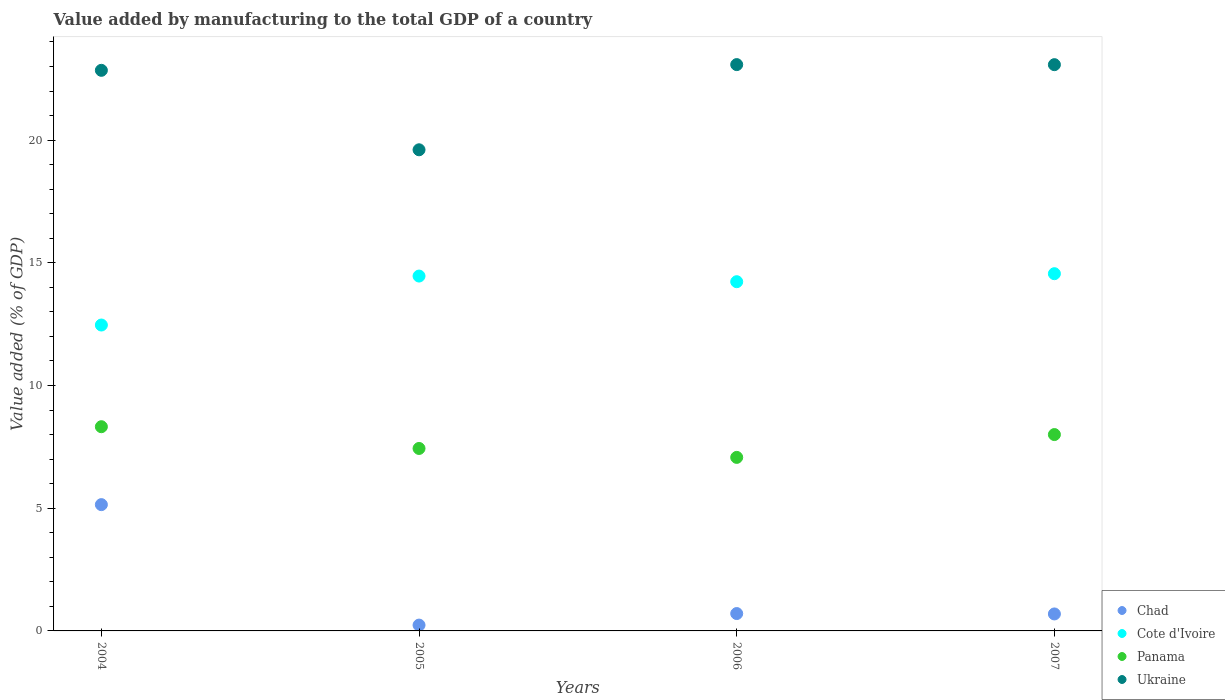What is the value added by manufacturing to the total GDP in Cote d'Ivoire in 2004?
Give a very brief answer. 12.47. Across all years, what is the maximum value added by manufacturing to the total GDP in Panama?
Offer a terse response. 8.32. Across all years, what is the minimum value added by manufacturing to the total GDP in Ukraine?
Keep it short and to the point. 19.61. In which year was the value added by manufacturing to the total GDP in Panama minimum?
Your answer should be compact. 2006. What is the total value added by manufacturing to the total GDP in Cote d'Ivoire in the graph?
Your answer should be very brief. 55.71. What is the difference between the value added by manufacturing to the total GDP in Chad in 2004 and that in 2006?
Ensure brevity in your answer.  4.44. What is the difference between the value added by manufacturing to the total GDP in Panama in 2006 and the value added by manufacturing to the total GDP in Cote d'Ivoire in 2004?
Your answer should be very brief. -5.39. What is the average value added by manufacturing to the total GDP in Cote d'Ivoire per year?
Make the answer very short. 13.93. In the year 2005, what is the difference between the value added by manufacturing to the total GDP in Cote d'Ivoire and value added by manufacturing to the total GDP in Ukraine?
Offer a very short reply. -5.15. What is the ratio of the value added by manufacturing to the total GDP in Cote d'Ivoire in 2006 to that in 2007?
Make the answer very short. 0.98. What is the difference between the highest and the second highest value added by manufacturing to the total GDP in Panama?
Keep it short and to the point. 0.32. What is the difference between the highest and the lowest value added by manufacturing to the total GDP in Panama?
Keep it short and to the point. 1.25. Is it the case that in every year, the sum of the value added by manufacturing to the total GDP in Ukraine and value added by manufacturing to the total GDP in Cote d'Ivoire  is greater than the value added by manufacturing to the total GDP in Panama?
Make the answer very short. Yes. Is the value added by manufacturing to the total GDP in Chad strictly less than the value added by manufacturing to the total GDP in Panama over the years?
Your answer should be very brief. Yes. How many dotlines are there?
Keep it short and to the point. 4. Are the values on the major ticks of Y-axis written in scientific E-notation?
Make the answer very short. No. Does the graph contain any zero values?
Offer a terse response. No. Where does the legend appear in the graph?
Provide a succinct answer. Bottom right. What is the title of the graph?
Provide a short and direct response. Value added by manufacturing to the total GDP of a country. What is the label or title of the Y-axis?
Your answer should be compact. Value added (% of GDP). What is the Value added (% of GDP) in Chad in 2004?
Give a very brief answer. 5.15. What is the Value added (% of GDP) in Cote d'Ivoire in 2004?
Your response must be concise. 12.47. What is the Value added (% of GDP) of Panama in 2004?
Your response must be concise. 8.32. What is the Value added (% of GDP) of Ukraine in 2004?
Give a very brief answer. 22.84. What is the Value added (% of GDP) of Chad in 2005?
Ensure brevity in your answer.  0.24. What is the Value added (% of GDP) of Cote d'Ivoire in 2005?
Your answer should be very brief. 14.46. What is the Value added (% of GDP) in Panama in 2005?
Your response must be concise. 7.44. What is the Value added (% of GDP) in Ukraine in 2005?
Keep it short and to the point. 19.61. What is the Value added (% of GDP) in Chad in 2006?
Offer a terse response. 0.71. What is the Value added (% of GDP) in Cote d'Ivoire in 2006?
Offer a terse response. 14.23. What is the Value added (% of GDP) in Panama in 2006?
Keep it short and to the point. 7.07. What is the Value added (% of GDP) in Ukraine in 2006?
Your response must be concise. 23.08. What is the Value added (% of GDP) in Chad in 2007?
Provide a succinct answer. 0.69. What is the Value added (% of GDP) in Cote d'Ivoire in 2007?
Offer a terse response. 14.56. What is the Value added (% of GDP) in Panama in 2007?
Your response must be concise. 8. What is the Value added (% of GDP) of Ukraine in 2007?
Provide a succinct answer. 23.07. Across all years, what is the maximum Value added (% of GDP) of Chad?
Make the answer very short. 5.15. Across all years, what is the maximum Value added (% of GDP) in Cote d'Ivoire?
Your response must be concise. 14.56. Across all years, what is the maximum Value added (% of GDP) in Panama?
Your answer should be compact. 8.32. Across all years, what is the maximum Value added (% of GDP) of Ukraine?
Make the answer very short. 23.08. Across all years, what is the minimum Value added (% of GDP) in Chad?
Offer a very short reply. 0.24. Across all years, what is the minimum Value added (% of GDP) in Cote d'Ivoire?
Your answer should be compact. 12.47. Across all years, what is the minimum Value added (% of GDP) in Panama?
Your answer should be very brief. 7.07. Across all years, what is the minimum Value added (% of GDP) in Ukraine?
Offer a terse response. 19.61. What is the total Value added (% of GDP) of Chad in the graph?
Ensure brevity in your answer.  6.78. What is the total Value added (% of GDP) of Cote d'Ivoire in the graph?
Offer a very short reply. 55.71. What is the total Value added (% of GDP) of Panama in the graph?
Offer a terse response. 30.83. What is the total Value added (% of GDP) in Ukraine in the graph?
Your answer should be very brief. 88.6. What is the difference between the Value added (% of GDP) of Chad in 2004 and that in 2005?
Ensure brevity in your answer.  4.91. What is the difference between the Value added (% of GDP) in Cote d'Ivoire in 2004 and that in 2005?
Provide a short and direct response. -2. What is the difference between the Value added (% of GDP) of Panama in 2004 and that in 2005?
Ensure brevity in your answer.  0.89. What is the difference between the Value added (% of GDP) in Ukraine in 2004 and that in 2005?
Provide a short and direct response. 3.24. What is the difference between the Value added (% of GDP) of Chad in 2004 and that in 2006?
Ensure brevity in your answer.  4.44. What is the difference between the Value added (% of GDP) of Cote d'Ivoire in 2004 and that in 2006?
Provide a succinct answer. -1.77. What is the difference between the Value added (% of GDP) of Panama in 2004 and that in 2006?
Your answer should be very brief. 1.25. What is the difference between the Value added (% of GDP) in Ukraine in 2004 and that in 2006?
Make the answer very short. -0.23. What is the difference between the Value added (% of GDP) in Chad in 2004 and that in 2007?
Your answer should be compact. 4.45. What is the difference between the Value added (% of GDP) in Cote d'Ivoire in 2004 and that in 2007?
Give a very brief answer. -2.09. What is the difference between the Value added (% of GDP) in Panama in 2004 and that in 2007?
Give a very brief answer. 0.32. What is the difference between the Value added (% of GDP) in Ukraine in 2004 and that in 2007?
Offer a very short reply. -0.23. What is the difference between the Value added (% of GDP) in Chad in 2005 and that in 2006?
Offer a very short reply. -0.47. What is the difference between the Value added (% of GDP) in Cote d'Ivoire in 2005 and that in 2006?
Provide a succinct answer. 0.23. What is the difference between the Value added (% of GDP) of Panama in 2005 and that in 2006?
Keep it short and to the point. 0.36. What is the difference between the Value added (% of GDP) in Ukraine in 2005 and that in 2006?
Ensure brevity in your answer.  -3.47. What is the difference between the Value added (% of GDP) of Chad in 2005 and that in 2007?
Offer a terse response. -0.45. What is the difference between the Value added (% of GDP) of Cote d'Ivoire in 2005 and that in 2007?
Offer a very short reply. -0.1. What is the difference between the Value added (% of GDP) in Panama in 2005 and that in 2007?
Offer a very short reply. -0.57. What is the difference between the Value added (% of GDP) of Ukraine in 2005 and that in 2007?
Give a very brief answer. -3.47. What is the difference between the Value added (% of GDP) of Chad in 2006 and that in 2007?
Your response must be concise. 0.02. What is the difference between the Value added (% of GDP) in Cote d'Ivoire in 2006 and that in 2007?
Your response must be concise. -0.33. What is the difference between the Value added (% of GDP) in Panama in 2006 and that in 2007?
Provide a short and direct response. -0.93. What is the difference between the Value added (% of GDP) of Ukraine in 2006 and that in 2007?
Provide a succinct answer. 0. What is the difference between the Value added (% of GDP) in Chad in 2004 and the Value added (% of GDP) in Cote d'Ivoire in 2005?
Provide a succinct answer. -9.31. What is the difference between the Value added (% of GDP) of Chad in 2004 and the Value added (% of GDP) of Panama in 2005?
Give a very brief answer. -2.29. What is the difference between the Value added (% of GDP) in Chad in 2004 and the Value added (% of GDP) in Ukraine in 2005?
Make the answer very short. -14.46. What is the difference between the Value added (% of GDP) of Cote d'Ivoire in 2004 and the Value added (% of GDP) of Panama in 2005?
Offer a terse response. 5.03. What is the difference between the Value added (% of GDP) of Cote d'Ivoire in 2004 and the Value added (% of GDP) of Ukraine in 2005?
Provide a succinct answer. -7.14. What is the difference between the Value added (% of GDP) in Panama in 2004 and the Value added (% of GDP) in Ukraine in 2005?
Ensure brevity in your answer.  -11.28. What is the difference between the Value added (% of GDP) of Chad in 2004 and the Value added (% of GDP) of Cote d'Ivoire in 2006?
Make the answer very short. -9.08. What is the difference between the Value added (% of GDP) in Chad in 2004 and the Value added (% of GDP) in Panama in 2006?
Keep it short and to the point. -1.93. What is the difference between the Value added (% of GDP) in Chad in 2004 and the Value added (% of GDP) in Ukraine in 2006?
Your response must be concise. -17.93. What is the difference between the Value added (% of GDP) of Cote d'Ivoire in 2004 and the Value added (% of GDP) of Panama in 2006?
Offer a terse response. 5.39. What is the difference between the Value added (% of GDP) in Cote d'Ivoire in 2004 and the Value added (% of GDP) in Ukraine in 2006?
Keep it short and to the point. -10.61. What is the difference between the Value added (% of GDP) in Panama in 2004 and the Value added (% of GDP) in Ukraine in 2006?
Make the answer very short. -14.76. What is the difference between the Value added (% of GDP) in Chad in 2004 and the Value added (% of GDP) in Cote d'Ivoire in 2007?
Ensure brevity in your answer.  -9.41. What is the difference between the Value added (% of GDP) in Chad in 2004 and the Value added (% of GDP) in Panama in 2007?
Make the answer very short. -2.86. What is the difference between the Value added (% of GDP) in Chad in 2004 and the Value added (% of GDP) in Ukraine in 2007?
Your response must be concise. -17.93. What is the difference between the Value added (% of GDP) in Cote d'Ivoire in 2004 and the Value added (% of GDP) in Panama in 2007?
Make the answer very short. 4.46. What is the difference between the Value added (% of GDP) in Cote d'Ivoire in 2004 and the Value added (% of GDP) in Ukraine in 2007?
Give a very brief answer. -10.61. What is the difference between the Value added (% of GDP) of Panama in 2004 and the Value added (% of GDP) of Ukraine in 2007?
Provide a succinct answer. -14.75. What is the difference between the Value added (% of GDP) of Chad in 2005 and the Value added (% of GDP) of Cote d'Ivoire in 2006?
Give a very brief answer. -13.99. What is the difference between the Value added (% of GDP) in Chad in 2005 and the Value added (% of GDP) in Panama in 2006?
Give a very brief answer. -6.83. What is the difference between the Value added (% of GDP) of Chad in 2005 and the Value added (% of GDP) of Ukraine in 2006?
Offer a terse response. -22.84. What is the difference between the Value added (% of GDP) in Cote d'Ivoire in 2005 and the Value added (% of GDP) in Panama in 2006?
Offer a very short reply. 7.39. What is the difference between the Value added (% of GDP) in Cote d'Ivoire in 2005 and the Value added (% of GDP) in Ukraine in 2006?
Give a very brief answer. -8.62. What is the difference between the Value added (% of GDP) of Panama in 2005 and the Value added (% of GDP) of Ukraine in 2006?
Make the answer very short. -15.64. What is the difference between the Value added (% of GDP) of Chad in 2005 and the Value added (% of GDP) of Cote d'Ivoire in 2007?
Make the answer very short. -14.32. What is the difference between the Value added (% of GDP) of Chad in 2005 and the Value added (% of GDP) of Panama in 2007?
Give a very brief answer. -7.76. What is the difference between the Value added (% of GDP) in Chad in 2005 and the Value added (% of GDP) in Ukraine in 2007?
Provide a succinct answer. -22.84. What is the difference between the Value added (% of GDP) of Cote d'Ivoire in 2005 and the Value added (% of GDP) of Panama in 2007?
Provide a short and direct response. 6.46. What is the difference between the Value added (% of GDP) in Cote d'Ivoire in 2005 and the Value added (% of GDP) in Ukraine in 2007?
Provide a succinct answer. -8.61. What is the difference between the Value added (% of GDP) of Panama in 2005 and the Value added (% of GDP) of Ukraine in 2007?
Make the answer very short. -15.64. What is the difference between the Value added (% of GDP) in Chad in 2006 and the Value added (% of GDP) in Cote d'Ivoire in 2007?
Ensure brevity in your answer.  -13.85. What is the difference between the Value added (% of GDP) of Chad in 2006 and the Value added (% of GDP) of Panama in 2007?
Your answer should be very brief. -7.29. What is the difference between the Value added (% of GDP) of Chad in 2006 and the Value added (% of GDP) of Ukraine in 2007?
Give a very brief answer. -22.37. What is the difference between the Value added (% of GDP) of Cote d'Ivoire in 2006 and the Value added (% of GDP) of Panama in 2007?
Provide a succinct answer. 6.23. What is the difference between the Value added (% of GDP) in Cote d'Ivoire in 2006 and the Value added (% of GDP) in Ukraine in 2007?
Ensure brevity in your answer.  -8.84. What is the difference between the Value added (% of GDP) of Panama in 2006 and the Value added (% of GDP) of Ukraine in 2007?
Give a very brief answer. -16. What is the average Value added (% of GDP) of Chad per year?
Your answer should be compact. 1.7. What is the average Value added (% of GDP) of Cote d'Ivoire per year?
Offer a very short reply. 13.93. What is the average Value added (% of GDP) in Panama per year?
Provide a succinct answer. 7.71. What is the average Value added (% of GDP) of Ukraine per year?
Your answer should be very brief. 22.15. In the year 2004, what is the difference between the Value added (% of GDP) of Chad and Value added (% of GDP) of Cote d'Ivoire?
Provide a short and direct response. -7.32. In the year 2004, what is the difference between the Value added (% of GDP) in Chad and Value added (% of GDP) in Panama?
Keep it short and to the point. -3.18. In the year 2004, what is the difference between the Value added (% of GDP) of Chad and Value added (% of GDP) of Ukraine?
Make the answer very short. -17.7. In the year 2004, what is the difference between the Value added (% of GDP) of Cote d'Ivoire and Value added (% of GDP) of Panama?
Your answer should be compact. 4.14. In the year 2004, what is the difference between the Value added (% of GDP) of Cote d'Ivoire and Value added (% of GDP) of Ukraine?
Keep it short and to the point. -10.38. In the year 2004, what is the difference between the Value added (% of GDP) in Panama and Value added (% of GDP) in Ukraine?
Provide a succinct answer. -14.52. In the year 2005, what is the difference between the Value added (% of GDP) in Chad and Value added (% of GDP) in Cote d'Ivoire?
Your response must be concise. -14.22. In the year 2005, what is the difference between the Value added (% of GDP) of Chad and Value added (% of GDP) of Panama?
Make the answer very short. -7.2. In the year 2005, what is the difference between the Value added (% of GDP) of Chad and Value added (% of GDP) of Ukraine?
Give a very brief answer. -19.37. In the year 2005, what is the difference between the Value added (% of GDP) in Cote d'Ivoire and Value added (% of GDP) in Panama?
Your response must be concise. 7.03. In the year 2005, what is the difference between the Value added (% of GDP) in Cote d'Ivoire and Value added (% of GDP) in Ukraine?
Ensure brevity in your answer.  -5.15. In the year 2005, what is the difference between the Value added (% of GDP) in Panama and Value added (% of GDP) in Ukraine?
Ensure brevity in your answer.  -12.17. In the year 2006, what is the difference between the Value added (% of GDP) in Chad and Value added (% of GDP) in Cote d'Ivoire?
Offer a very short reply. -13.52. In the year 2006, what is the difference between the Value added (% of GDP) of Chad and Value added (% of GDP) of Panama?
Keep it short and to the point. -6.36. In the year 2006, what is the difference between the Value added (% of GDP) in Chad and Value added (% of GDP) in Ukraine?
Provide a short and direct response. -22.37. In the year 2006, what is the difference between the Value added (% of GDP) in Cote d'Ivoire and Value added (% of GDP) in Panama?
Keep it short and to the point. 7.16. In the year 2006, what is the difference between the Value added (% of GDP) in Cote d'Ivoire and Value added (% of GDP) in Ukraine?
Make the answer very short. -8.85. In the year 2006, what is the difference between the Value added (% of GDP) of Panama and Value added (% of GDP) of Ukraine?
Offer a very short reply. -16.01. In the year 2007, what is the difference between the Value added (% of GDP) of Chad and Value added (% of GDP) of Cote d'Ivoire?
Make the answer very short. -13.87. In the year 2007, what is the difference between the Value added (% of GDP) in Chad and Value added (% of GDP) in Panama?
Your response must be concise. -7.31. In the year 2007, what is the difference between the Value added (% of GDP) in Chad and Value added (% of GDP) in Ukraine?
Provide a short and direct response. -22.38. In the year 2007, what is the difference between the Value added (% of GDP) in Cote d'Ivoire and Value added (% of GDP) in Panama?
Offer a terse response. 6.56. In the year 2007, what is the difference between the Value added (% of GDP) of Cote d'Ivoire and Value added (% of GDP) of Ukraine?
Provide a succinct answer. -8.52. In the year 2007, what is the difference between the Value added (% of GDP) in Panama and Value added (% of GDP) in Ukraine?
Provide a succinct answer. -15.07. What is the ratio of the Value added (% of GDP) in Chad in 2004 to that in 2005?
Your answer should be very brief. 21.71. What is the ratio of the Value added (% of GDP) in Cote d'Ivoire in 2004 to that in 2005?
Your response must be concise. 0.86. What is the ratio of the Value added (% of GDP) of Panama in 2004 to that in 2005?
Offer a terse response. 1.12. What is the ratio of the Value added (% of GDP) in Ukraine in 2004 to that in 2005?
Keep it short and to the point. 1.17. What is the ratio of the Value added (% of GDP) of Chad in 2004 to that in 2006?
Your answer should be very brief. 7.27. What is the ratio of the Value added (% of GDP) in Cote d'Ivoire in 2004 to that in 2006?
Your answer should be very brief. 0.88. What is the ratio of the Value added (% of GDP) of Panama in 2004 to that in 2006?
Give a very brief answer. 1.18. What is the ratio of the Value added (% of GDP) of Ukraine in 2004 to that in 2006?
Offer a terse response. 0.99. What is the ratio of the Value added (% of GDP) of Chad in 2004 to that in 2007?
Provide a succinct answer. 7.44. What is the ratio of the Value added (% of GDP) of Cote d'Ivoire in 2004 to that in 2007?
Make the answer very short. 0.86. What is the ratio of the Value added (% of GDP) of Ukraine in 2004 to that in 2007?
Make the answer very short. 0.99. What is the ratio of the Value added (% of GDP) in Chad in 2005 to that in 2006?
Offer a very short reply. 0.34. What is the ratio of the Value added (% of GDP) in Cote d'Ivoire in 2005 to that in 2006?
Provide a short and direct response. 1.02. What is the ratio of the Value added (% of GDP) of Panama in 2005 to that in 2006?
Your answer should be very brief. 1.05. What is the ratio of the Value added (% of GDP) in Ukraine in 2005 to that in 2006?
Offer a very short reply. 0.85. What is the ratio of the Value added (% of GDP) of Chad in 2005 to that in 2007?
Your response must be concise. 0.34. What is the ratio of the Value added (% of GDP) in Cote d'Ivoire in 2005 to that in 2007?
Ensure brevity in your answer.  0.99. What is the ratio of the Value added (% of GDP) in Panama in 2005 to that in 2007?
Provide a short and direct response. 0.93. What is the ratio of the Value added (% of GDP) of Ukraine in 2005 to that in 2007?
Your response must be concise. 0.85. What is the ratio of the Value added (% of GDP) of Chad in 2006 to that in 2007?
Your answer should be very brief. 1.02. What is the ratio of the Value added (% of GDP) of Cote d'Ivoire in 2006 to that in 2007?
Give a very brief answer. 0.98. What is the ratio of the Value added (% of GDP) of Panama in 2006 to that in 2007?
Provide a short and direct response. 0.88. What is the ratio of the Value added (% of GDP) in Ukraine in 2006 to that in 2007?
Your answer should be very brief. 1. What is the difference between the highest and the second highest Value added (% of GDP) of Chad?
Make the answer very short. 4.44. What is the difference between the highest and the second highest Value added (% of GDP) in Cote d'Ivoire?
Offer a terse response. 0.1. What is the difference between the highest and the second highest Value added (% of GDP) in Panama?
Your response must be concise. 0.32. What is the difference between the highest and the second highest Value added (% of GDP) of Ukraine?
Your response must be concise. 0. What is the difference between the highest and the lowest Value added (% of GDP) of Chad?
Provide a succinct answer. 4.91. What is the difference between the highest and the lowest Value added (% of GDP) of Cote d'Ivoire?
Keep it short and to the point. 2.09. What is the difference between the highest and the lowest Value added (% of GDP) of Panama?
Make the answer very short. 1.25. What is the difference between the highest and the lowest Value added (% of GDP) in Ukraine?
Provide a succinct answer. 3.47. 